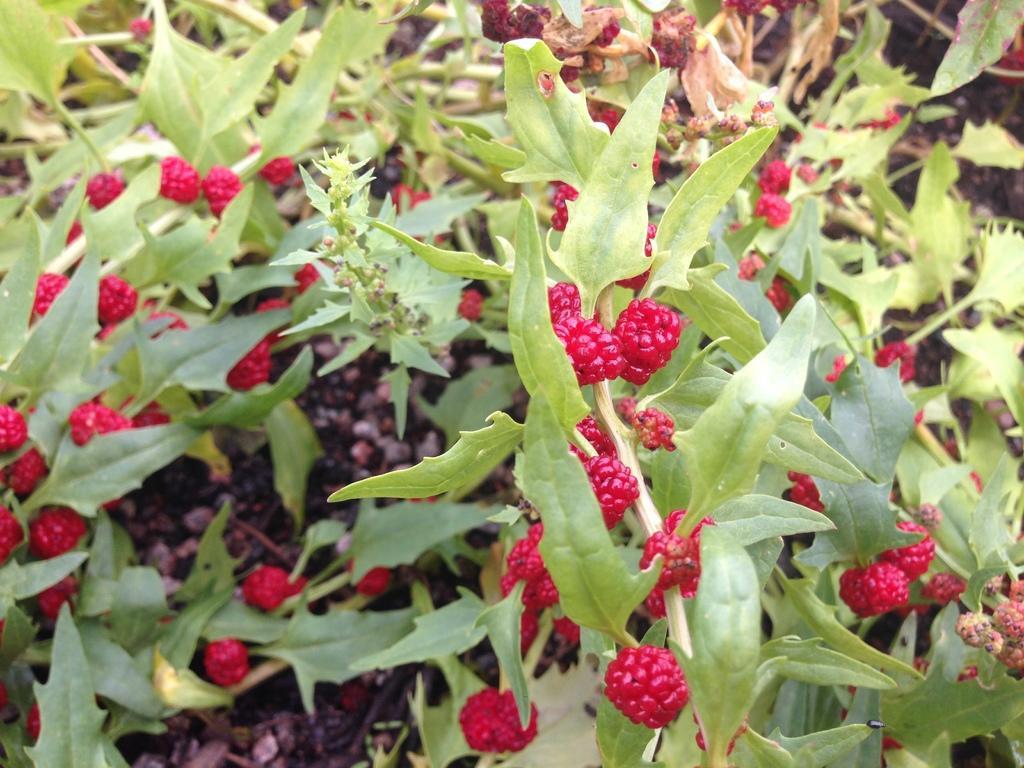What type of fruit is present in the image? There are raspberries in the image. What else can be seen in the image besides the raspberries? There are plants in the image. What type of drug can be seen in the image? There is no drug present in the image; it features raspberries and plants. 